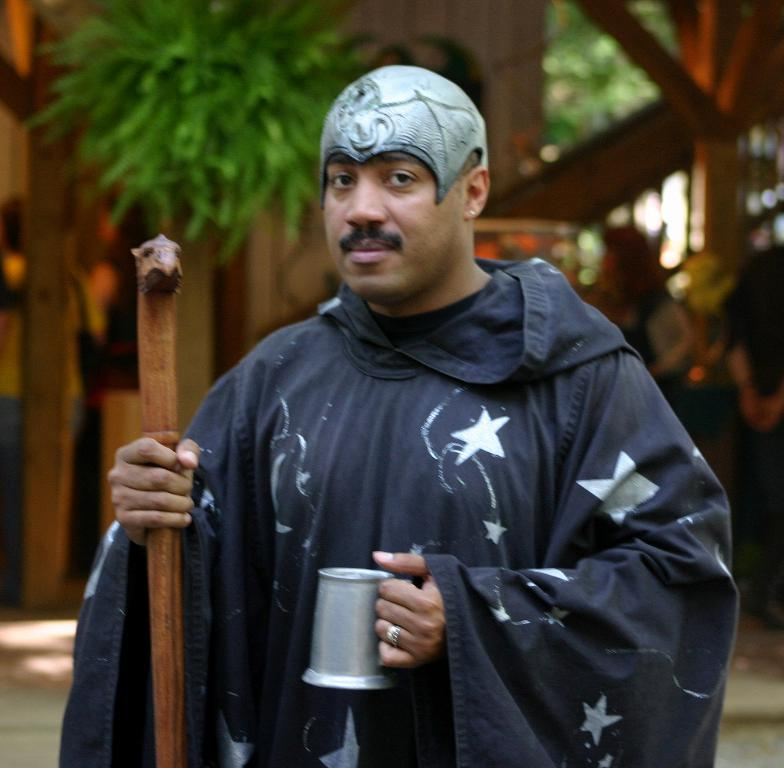What is the main subject of the image? There is a person standing in the center of the image. What is the person holding in the image? The person is holding a mug and a stick. What can be seen in the background of the image? There is a house, trees, and other persons in the background of the image. How does the zephyr affect the person holding the mug in the image? There is no mention of a zephyr or any wind in the image, so it cannot be determined how it would affect the person holding the mug. 